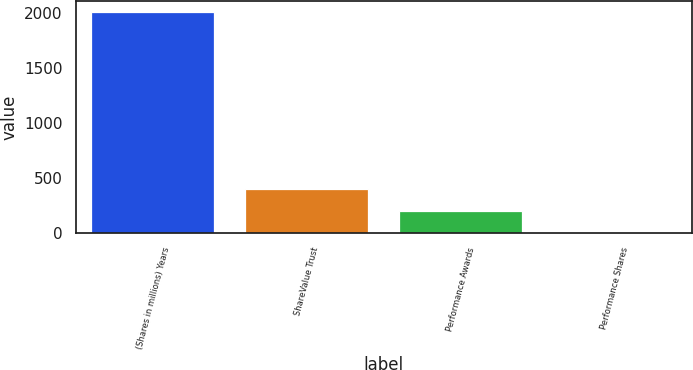Convert chart. <chart><loc_0><loc_0><loc_500><loc_500><bar_chart><fcel>(Shares in millions) Years<fcel>ShareValue Trust<fcel>Performance Awards<fcel>Performance Shares<nl><fcel>2008<fcel>402.16<fcel>201.43<fcel>0.7<nl></chart> 